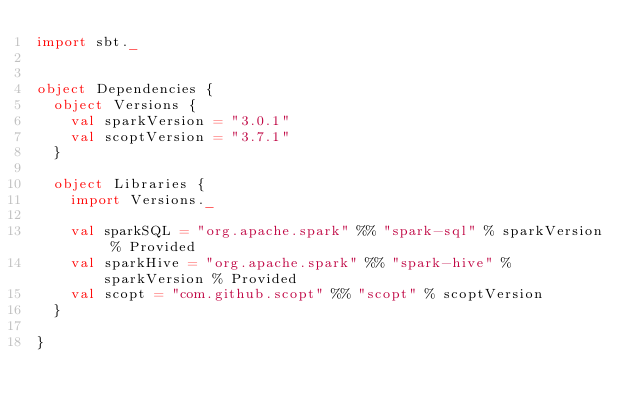Convert code to text. <code><loc_0><loc_0><loc_500><loc_500><_Scala_>import sbt._


object Dependencies {
  object Versions {
    val sparkVersion = "3.0.1"
    val scoptVersion = "3.7.1"
  }

  object Libraries {
    import Versions._

    val sparkSQL = "org.apache.spark" %% "spark-sql" % sparkVersion % Provided
    val sparkHive = "org.apache.spark" %% "spark-hive" % sparkVersion % Provided
    val scopt = "com.github.scopt" %% "scopt" % scoptVersion
  }

}
</code> 